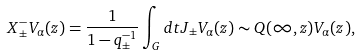Convert formula to latex. <formula><loc_0><loc_0><loc_500><loc_500>X _ { \pm } ^ { - } V _ { \alpha } ( z ) = \frac { 1 } { 1 - q _ { \pm } ^ { - 1 } } \int _ { G } d t J _ { \pm } V _ { \alpha } ( z ) \sim Q ( \infty , z ) V _ { \alpha } ( z ) ,</formula> 